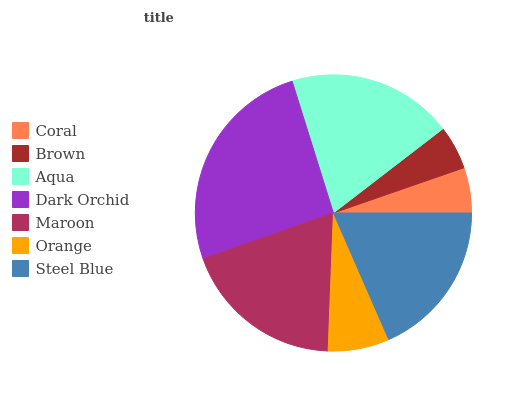Is Brown the minimum?
Answer yes or no. Yes. Is Dark Orchid the maximum?
Answer yes or no. Yes. Is Aqua the minimum?
Answer yes or no. No. Is Aqua the maximum?
Answer yes or no. No. Is Aqua greater than Brown?
Answer yes or no. Yes. Is Brown less than Aqua?
Answer yes or no. Yes. Is Brown greater than Aqua?
Answer yes or no. No. Is Aqua less than Brown?
Answer yes or no. No. Is Steel Blue the high median?
Answer yes or no. Yes. Is Steel Blue the low median?
Answer yes or no. Yes. Is Dark Orchid the high median?
Answer yes or no. No. Is Dark Orchid the low median?
Answer yes or no. No. 